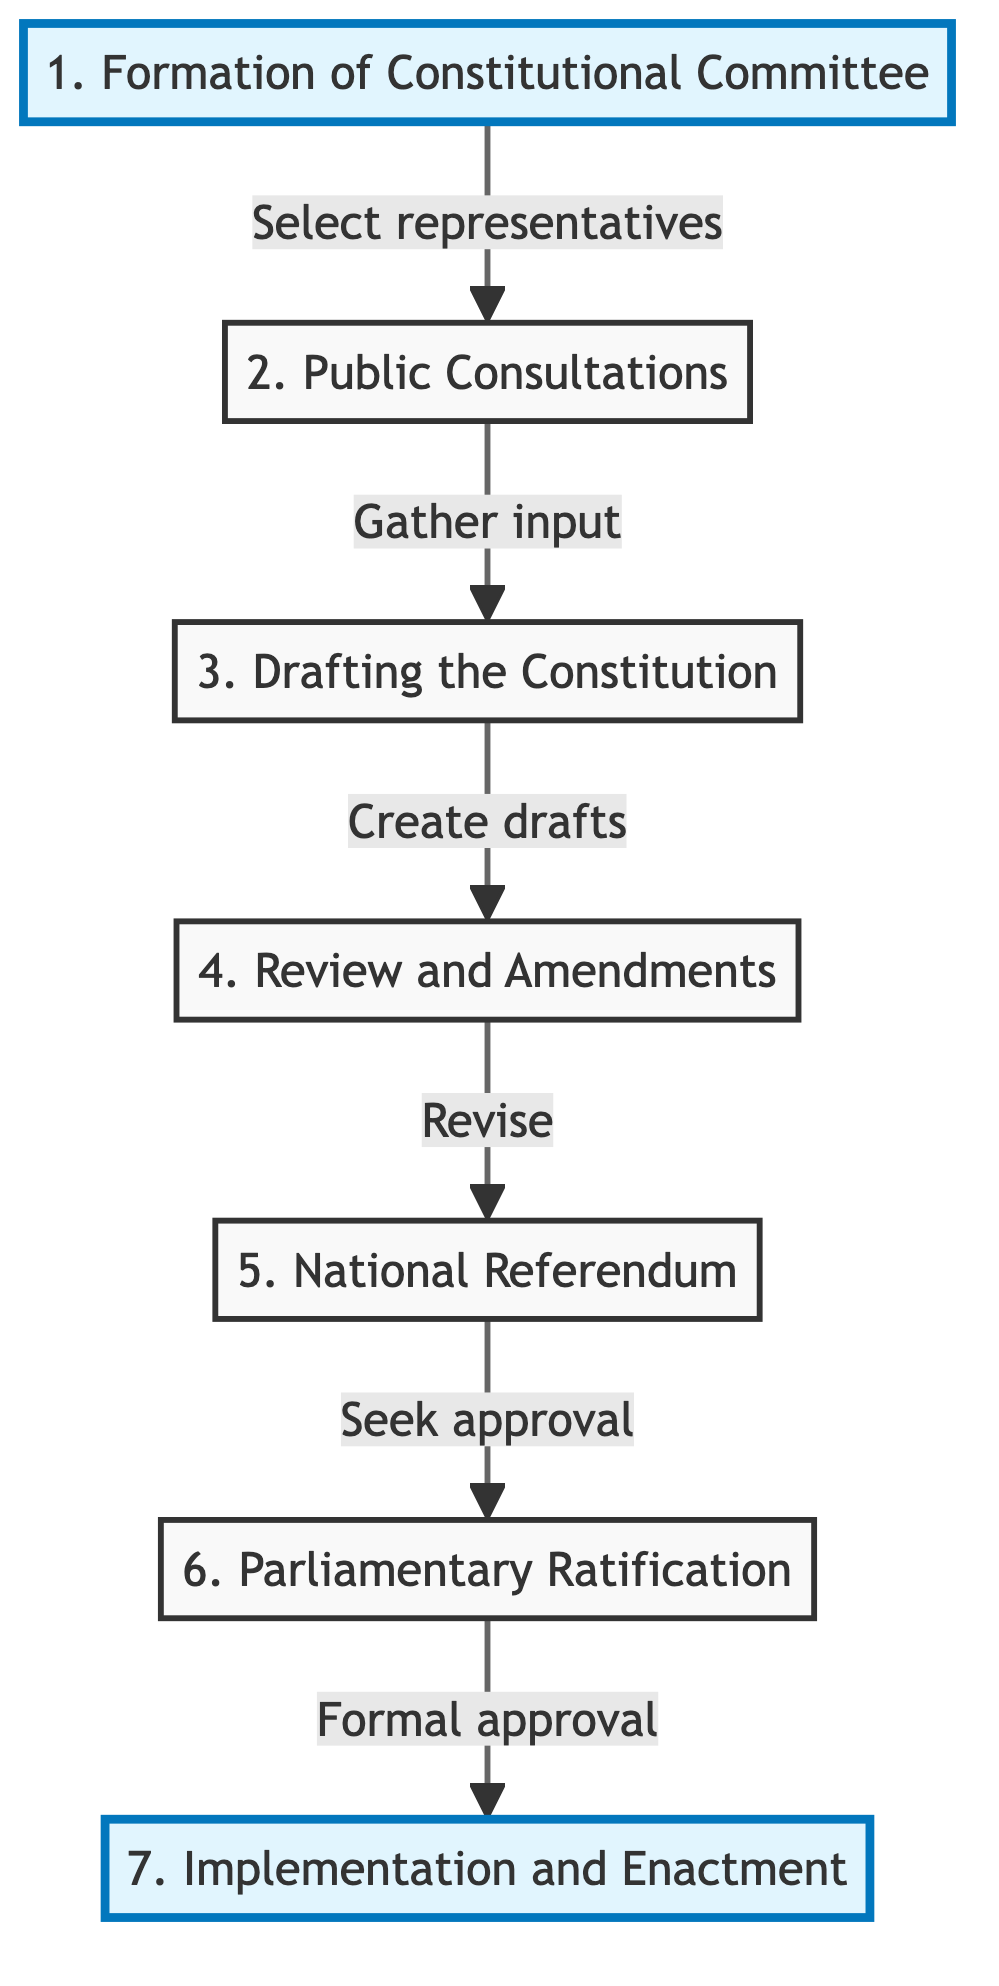What is the first step in the constitution drafting process? The diagram indicates that the first step is the "Formation of Constitutional Committee," where representatives and experts are selected.
Answer: Formation of Constitutional Committee How many steps are there in total? By counting the distinct steps listed in the diagram, we see that there are seven steps in the constitution drafting and ratification process.
Answer: Seven What type of input is sought in the second step? The second step, "Public Consultations," involves gathering input and opinions from the public and various stakeholders.
Answer: Input Which step follows the "Review and Amendments"? According to the flow in the diagram, the step that follows "Review and Amendments" is "National Referendum."
Answer: National Referendum What is the purpose of the "National Referendum"? The purpose of the "National Referendum" step is to seek approval from the citizens for the drafted constitution.
Answer: Approval How is the constitution finalized after the "Parliamentary Ratification"? The diagram states that after "Parliamentary Ratification," the constitution is officially enacted and its provisions implemented.
Answer: Enacted and implemented In which step are "initial drafts" created? The step where "initial drafts" are created is the "Drafting the Constitution." This is where iterations occur based on feedback.
Answer: Drafting the Constitution What is the main activity in the "Formation of Constitutional Committee"? The main activity in this step is selecting representatives and experts to be involved in drafting the constitution.
Answer: Selecting representatives What kind of process does the "Review and Amendments" step encompass? The "Review and Amendments" step encompasses the process of revising the draft based on reviews from experts and stakeholders.
Answer: Revising the draft 